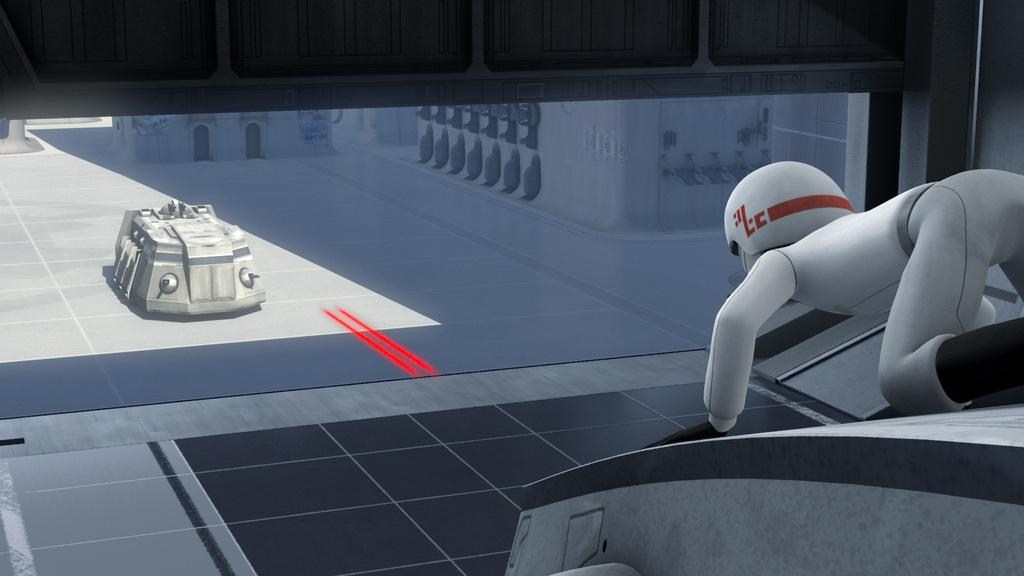What type of image is being described? The image is an animated image. Can you describe the person in the image? There is a person on the right side of the image. What else can be seen on the left side of the image? There is a vehicle on the left side of the image. What type of kitty can be seen playing with a range in the image? There is no kitty or range present in the image; it features an animated person and a vehicle. What type of soup is being served in the image? There is no soup present in the image. 